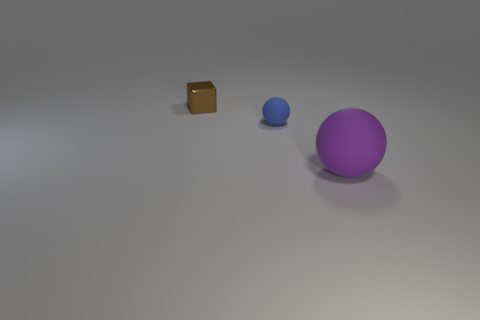The rubber ball that is in front of the ball on the left side of the large purple sphere is what color?
Ensure brevity in your answer.  Purple. Is the color of the matte object that is behind the purple thing the same as the large matte ball?
Offer a very short reply. No. What is the tiny thing that is in front of the small metallic block made of?
Give a very brief answer. Rubber. The purple sphere is what size?
Ensure brevity in your answer.  Large. Does the small object that is in front of the tiny brown metal object have the same material as the small brown object?
Your answer should be compact. No. What number of blue matte objects are there?
Give a very brief answer. 1. How many objects are big purple rubber objects or small brown blocks?
Your answer should be compact. 2. There is a ball that is on the left side of the matte sphere in front of the blue ball; how many rubber things are in front of it?
Your response must be concise. 1. Is there anything else that has the same color as the metallic object?
Your answer should be compact. No. Are there more things that are in front of the metal object than tiny brown metal things that are to the right of the big matte sphere?
Offer a very short reply. Yes. 